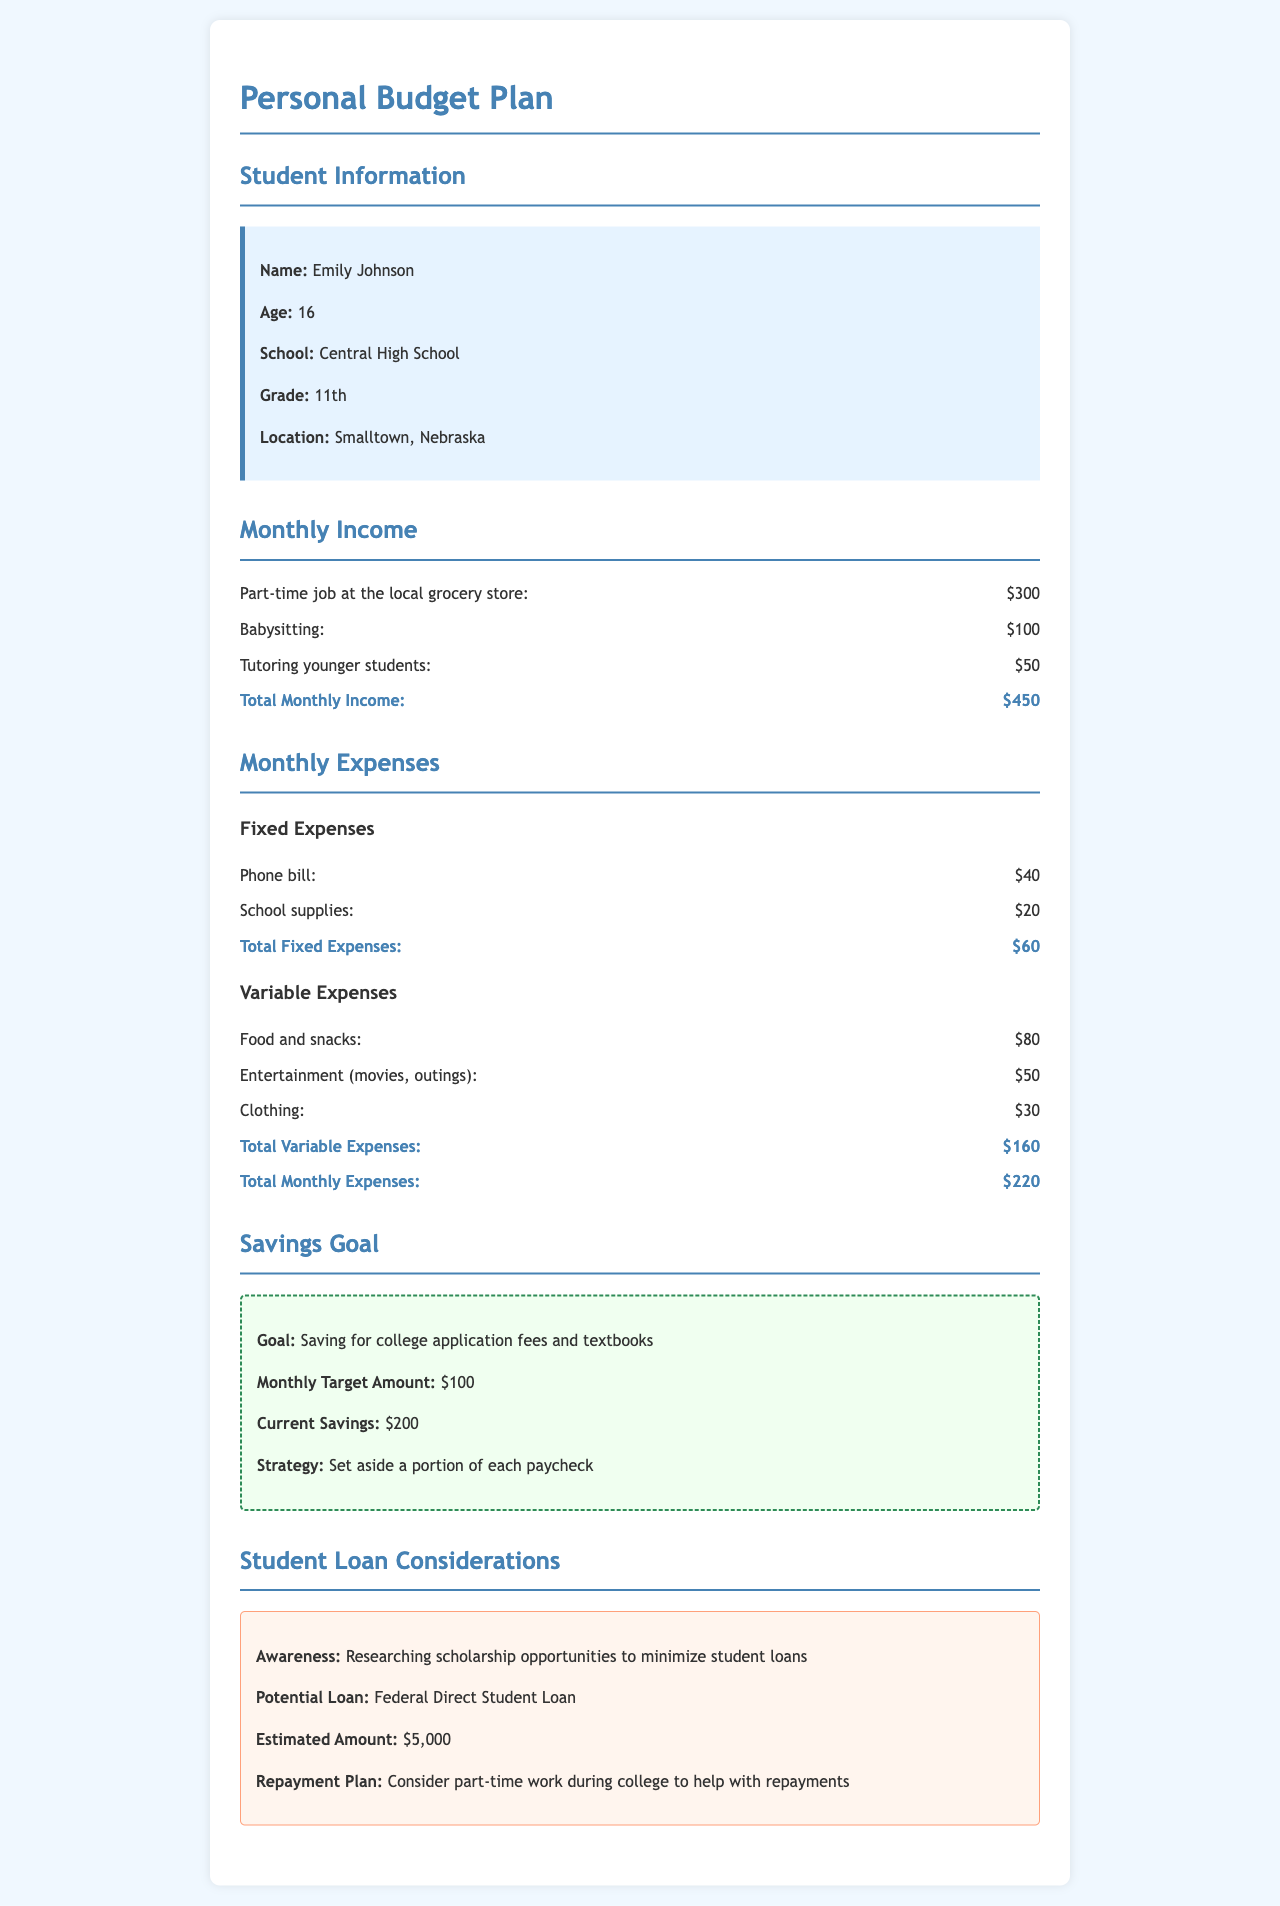What is Emily's age? Emily's age is specifically mentioned in the student information section of the document.
Answer: 16 What is the total monthly income? The total monthly income is calculated by summing all income sources listed in the monthly income section.
Answer: $450 What are the fixed expenses? Fixed expenses consist of the outlined regular payments such as the phone bill and school supplies.
Answer: $60 What is the monthly target amount for savings? The monthly target amount for savings is stated under the savings goal section of the document.
Answer: $100 What is Emily's current savings? Current savings is specified as part of the savings goal outlined in the document.
Answer: $200 Which loan is Emily considering? The document mentions the specific type of loan Emily is considering in the student loan considerations section.
Answer: Federal Direct Student Loan What is the estimated amount for potential loans? Estimated amounts for loans are provided in the student loan considerations section of the document.
Answer: $5,000 What is Emily's strategy for saving? The savings strategy is briefly described in the savings goal section of the document.
Answer: Set aside a portion of each paycheck How does Emily plan to handle student loan repayments? Emily's approach to dealing with loan repayments after college is mentioned in the student loan considerations section.
Answer: Part-time work during college 